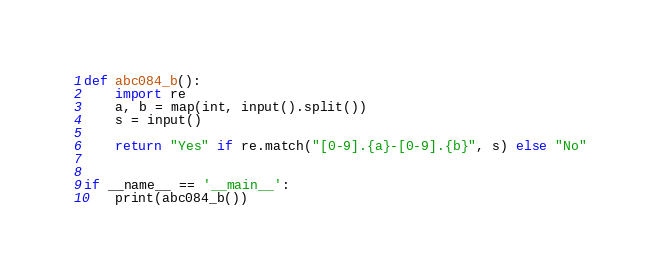Convert code to text. <code><loc_0><loc_0><loc_500><loc_500><_Python_>def abc084_b():
    import re
    a, b = map(int, input().split())
    s = input()

    return "Yes" if re.match("[0-9].{a}-[0-9].{b}", s) else "No"


if __name__ == '__main__':
    print(abc084_b())</code> 